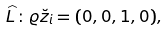Convert formula to latex. <formula><loc_0><loc_0><loc_500><loc_500>\widehat { L } \colon \varrho \breve { z } _ { i } = ( 0 , 0 , 1 , 0 ) ,</formula> 